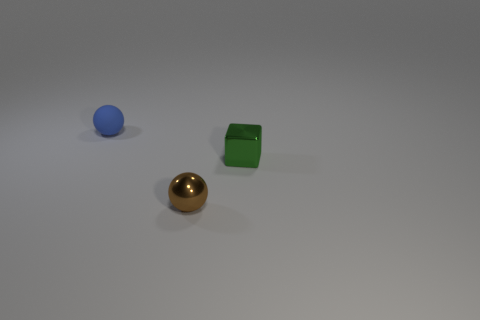Subtract all green spheres. Subtract all red blocks. How many spheres are left? 2 Add 3 small red metallic objects. How many objects exist? 6 Subtract all blocks. How many objects are left? 2 Add 2 cyan matte cylinders. How many cyan matte cylinders exist? 2 Subtract 0 brown cylinders. How many objects are left? 3 Subtract all blue shiny blocks. Subtract all small things. How many objects are left? 0 Add 1 green shiny objects. How many green shiny objects are left? 2 